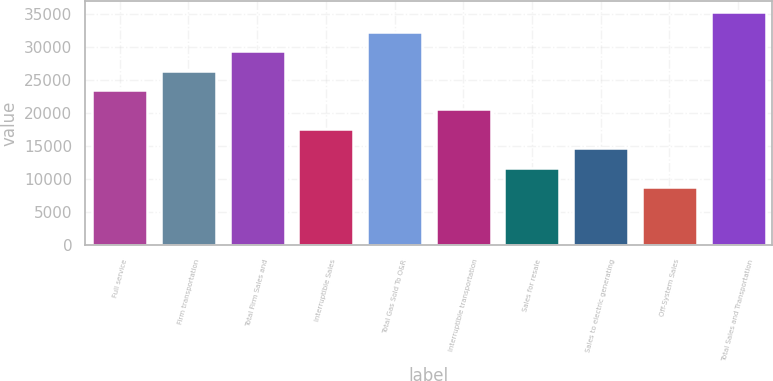Convert chart. <chart><loc_0><loc_0><loc_500><loc_500><bar_chart><fcel>Full service<fcel>Firm transportation<fcel>Total Firm Sales and<fcel>Interruptible Sales<fcel>Total Gas Sold To O&R<fcel>Interruptible transportation<fcel>Sales for resale<fcel>Sales to electric generating<fcel>Off-System Sales<fcel>Total Sales and Transportation<nl><fcel>23479.6<fcel>26413.3<fcel>29347<fcel>17612.2<fcel>32280.7<fcel>20545.9<fcel>11744.8<fcel>14678.5<fcel>8811.1<fcel>35214.4<nl></chart> 